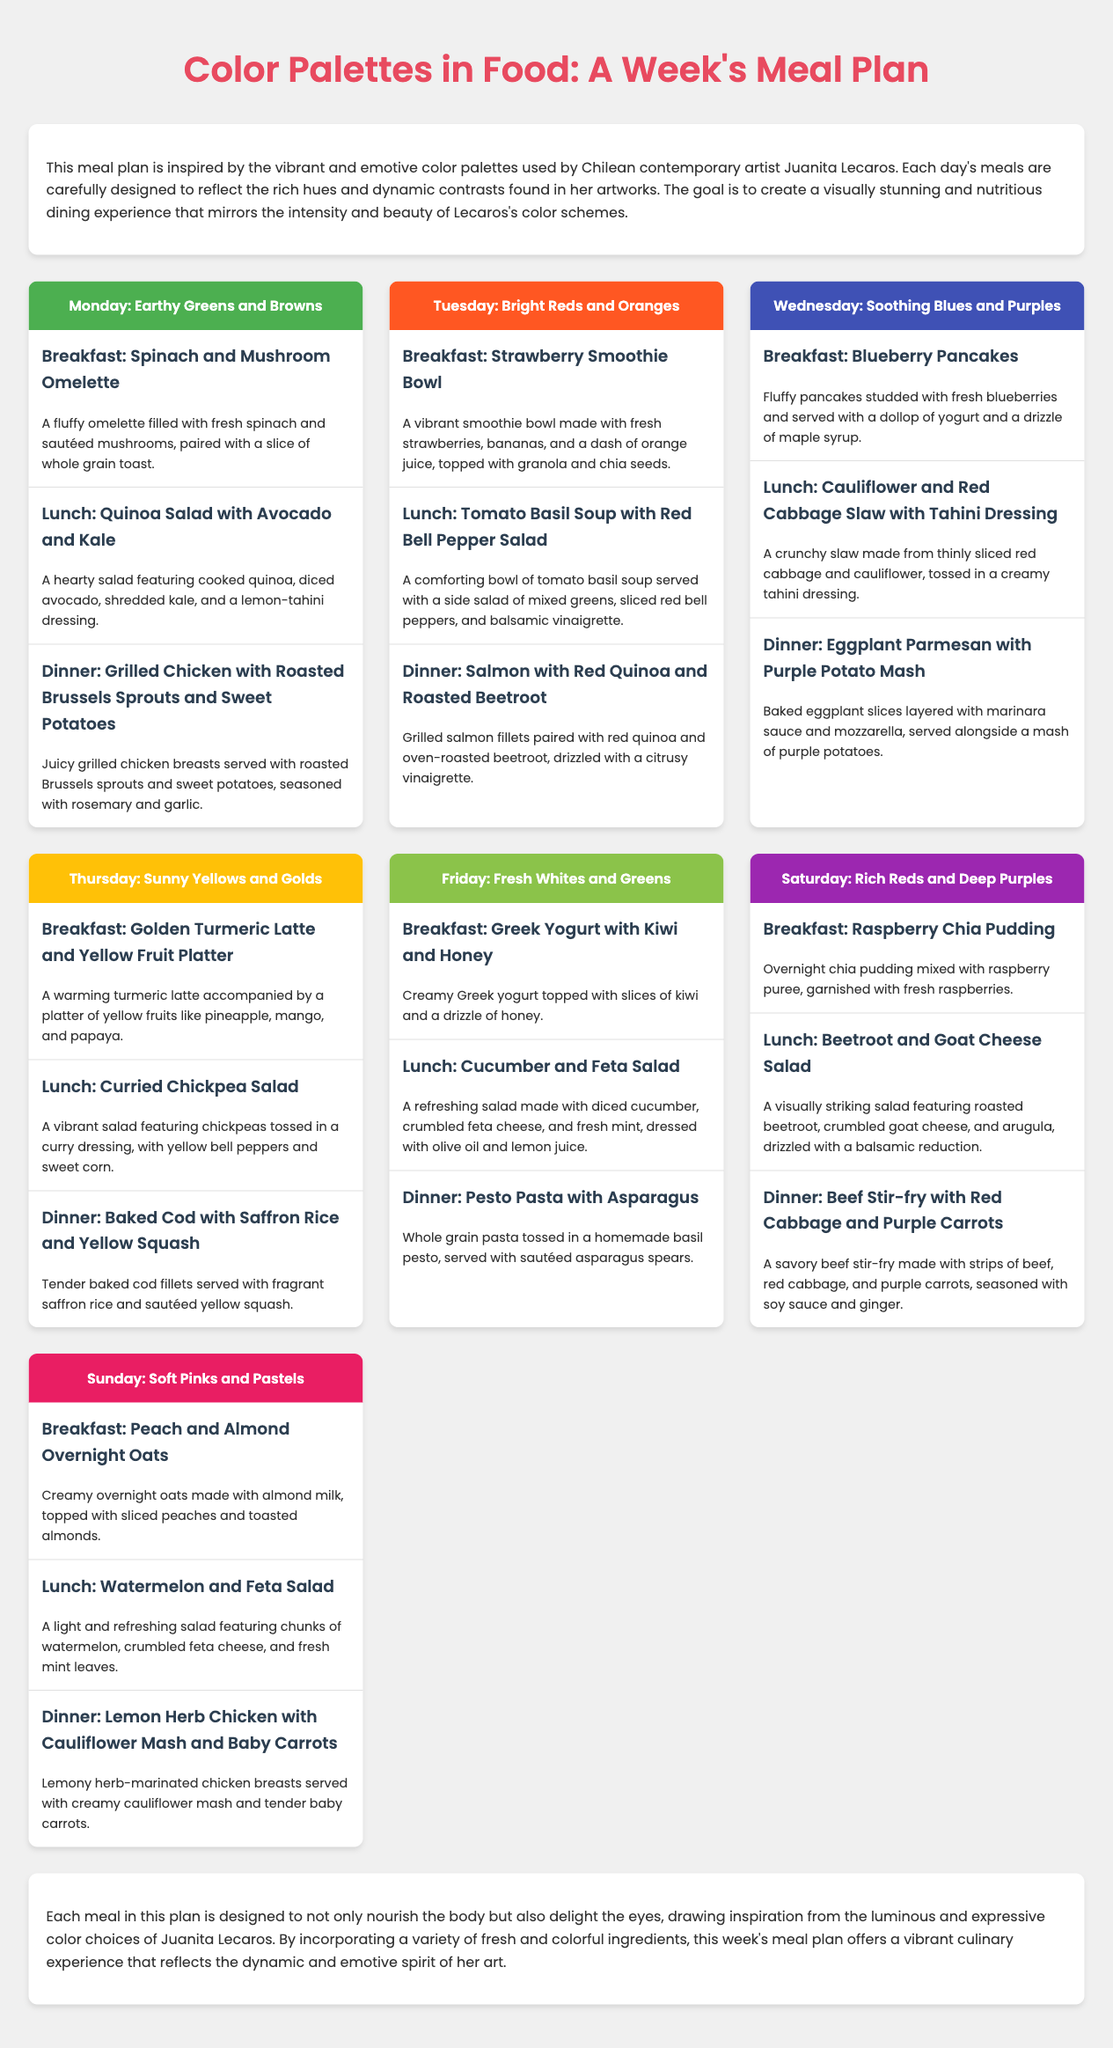What is the theme of the meal plan? The meal plan is inspired by the vibrant and emotive color palettes used by Chilean contemporary artist Juanita Lecaros.
Answer: Color palettes in food What meal is served for breakfast on Tuesday? Each day's breakfast is highlighted in the document, and for Tuesday, it specifically states the meal.
Answer: Strawberry Smoothie Bowl How many meals are suggested for each day? The structure of the meal plan includes three meals per day, listed clearly under each day's section.
Answer: Three Which color palette corresponds to Friday? Each day has a designated color palette, and Friday is specified in the corresponding section.
Answer: Fresh Whites and Greens What fruit is included in the Thursday breakfast? The breakfast for Thursday includes a specific type of fruit, detailed in the meal description.
Answer: Yellow fruits What main ingredient is featured in the Wednesday lunch? The lunch for Wednesday includes a specific ingredient used in the slaw, mentioned in the meal details.
Answer: Cauliflower What type of fish is included in the Tuesday dinner? The dinner for Tuesday specifies the type of fish that is included, as described in the meal section.
Answer: Salmon What ingredient is present in all meals across the week? Analyzing the meals across the week, certain ingredients like vegetables are common in various recipes.
Answer: Vegetables What is the main color theme of Saturday? Each day is dedicated to a specific color scheme, which is described at the start of Saturday's section.
Answer: Rich Reds and Deep Purples 